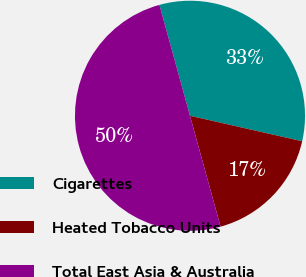<chart> <loc_0><loc_0><loc_500><loc_500><pie_chart><fcel>Cigarettes<fcel>Heated Tobacco Units<fcel>Total East Asia & Australia<nl><fcel>32.84%<fcel>17.16%<fcel>50.0%<nl></chart> 